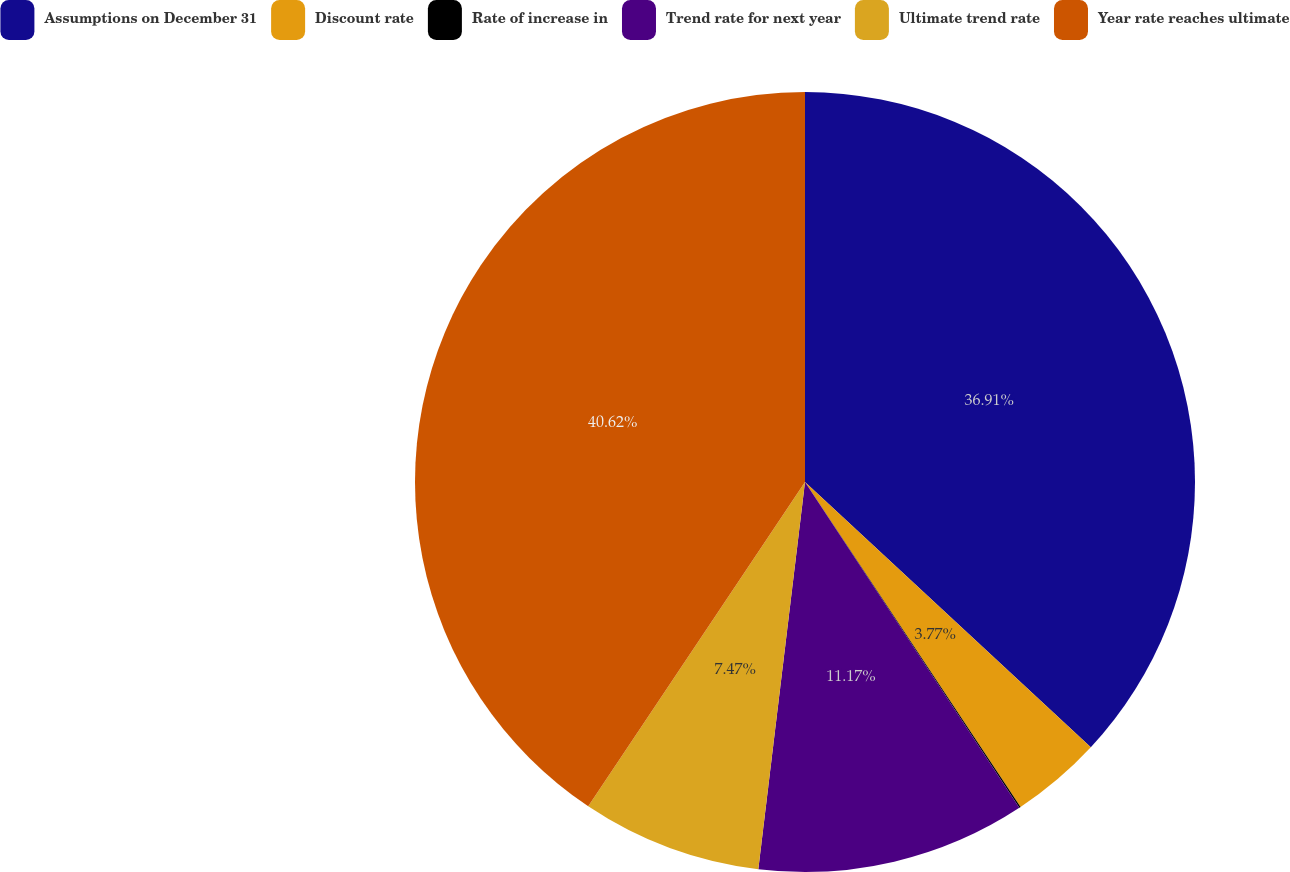<chart> <loc_0><loc_0><loc_500><loc_500><pie_chart><fcel>Assumptions on December 31<fcel>Discount rate<fcel>Rate of increase in<fcel>Trend rate for next year<fcel>Ultimate trend rate<fcel>Year rate reaches ultimate<nl><fcel>36.91%<fcel>3.77%<fcel>0.06%<fcel>11.17%<fcel>7.47%<fcel>40.62%<nl></chart> 